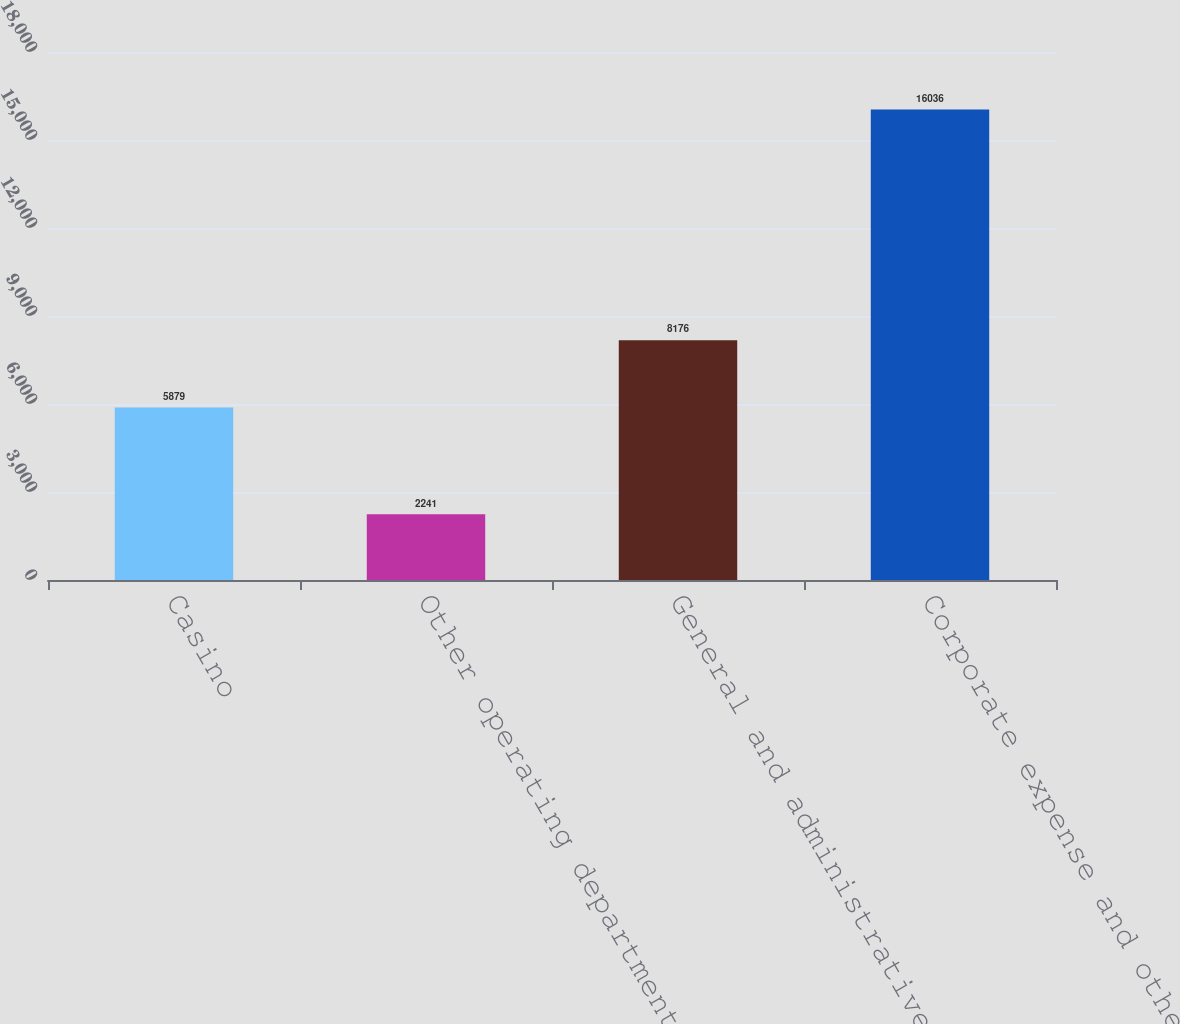<chart> <loc_0><loc_0><loc_500><loc_500><bar_chart><fcel>Casino<fcel>Other operating departments<fcel>General and administrative<fcel>Corporate expense and other<nl><fcel>5879<fcel>2241<fcel>8176<fcel>16036<nl></chart> 